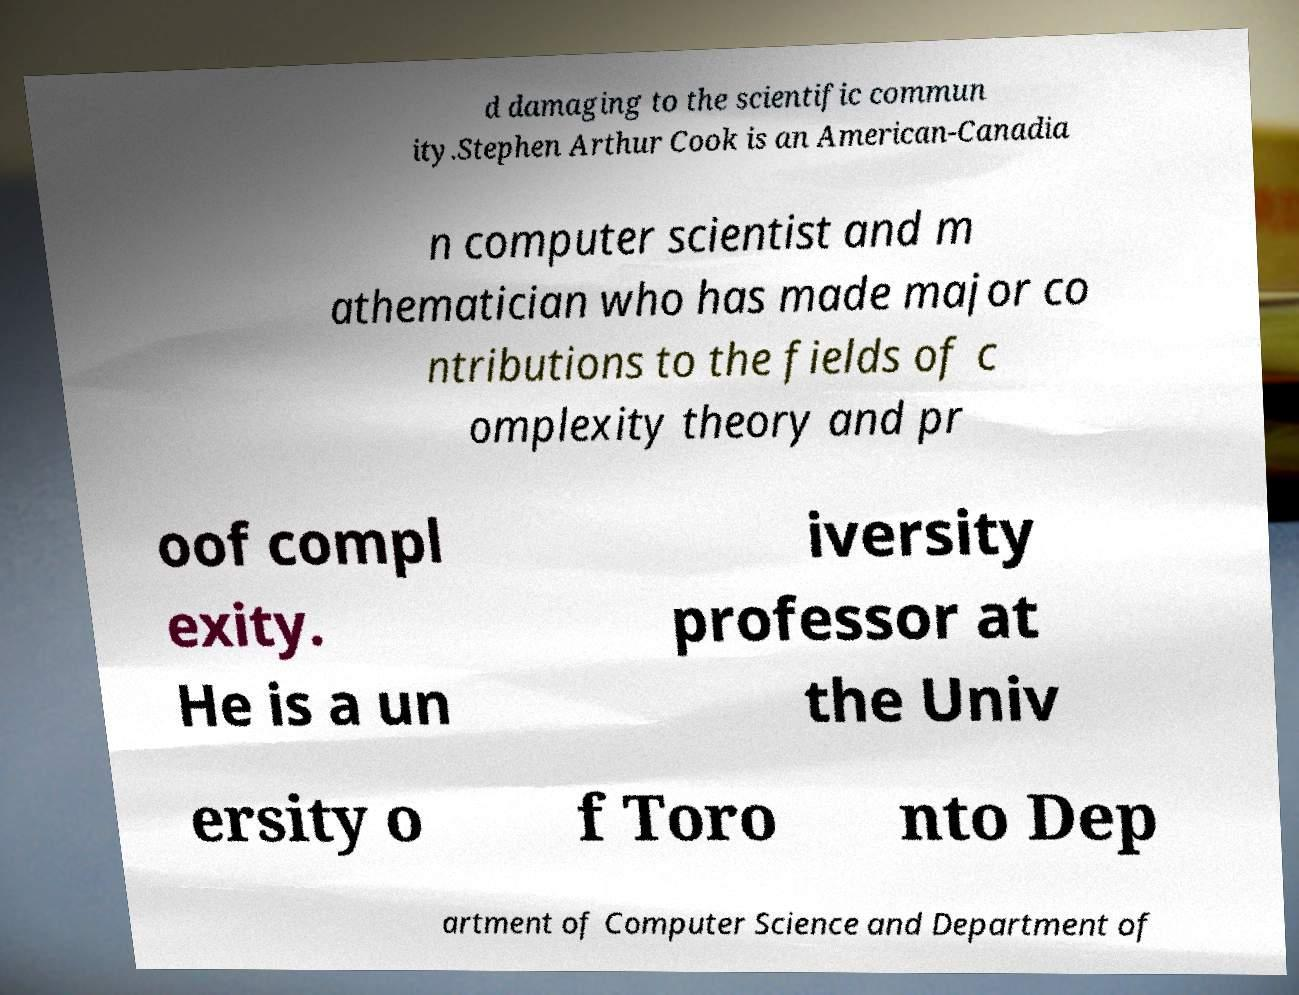I need the written content from this picture converted into text. Can you do that? d damaging to the scientific commun ity.Stephen Arthur Cook is an American-Canadia n computer scientist and m athematician who has made major co ntributions to the fields of c omplexity theory and pr oof compl exity. He is a un iversity professor at the Univ ersity o f Toro nto Dep artment of Computer Science and Department of 